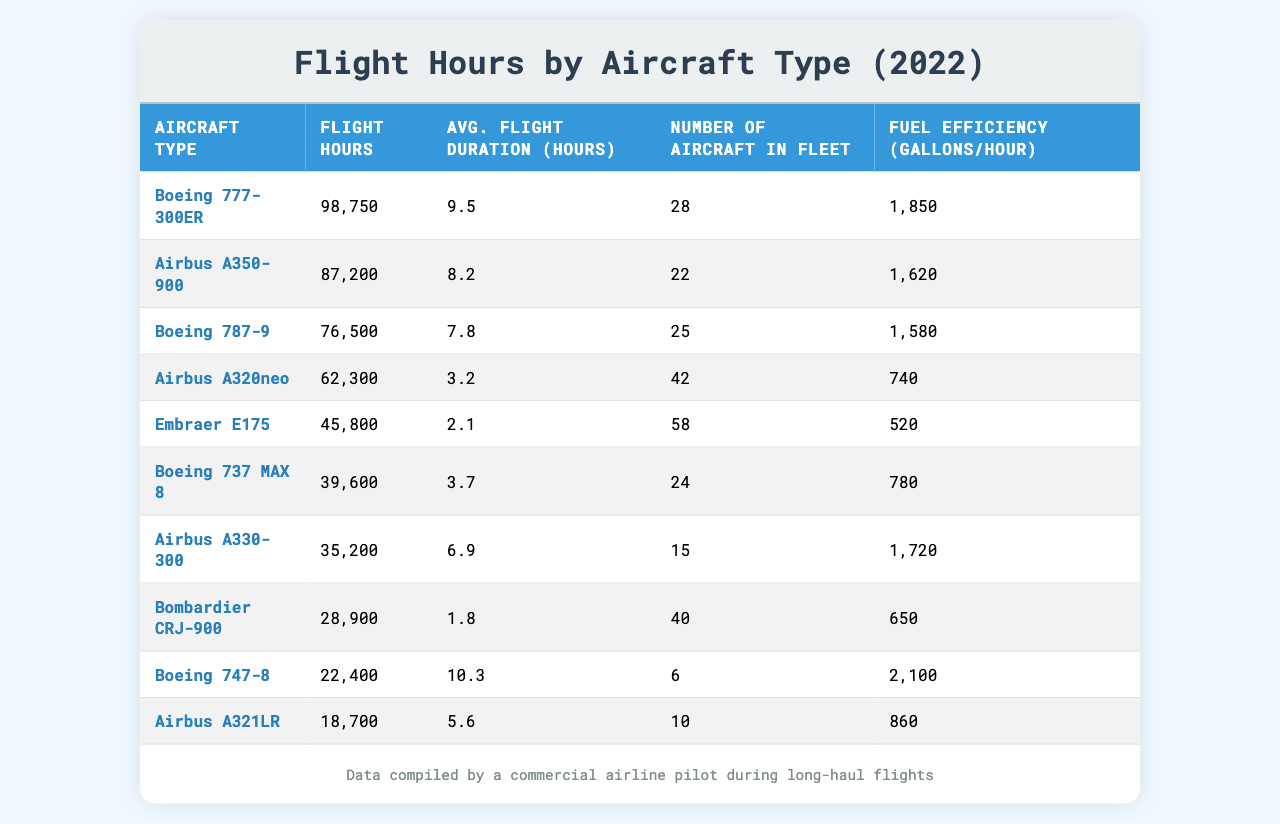What is the total flight hours logged by the Boeing 777-300ER? The table shows the flight hours for the Boeing 777-300ER as 98,750.
Answer: 98,750 Which aircraft type has the highest flight hours? The Boeing 777-300ER has the most flight hours logged at 98,750, which is listed first in the table.
Answer: Boeing 777-300ER What is the average flight duration for the Airbus A350-900? The average flight duration for the Airbus A350-900 is 8.2 hours, as shown directly in the appropriate cell of the table.
Answer: 8.2 How many aircraft are in the fleet for the Boeing 787-9? The number of Boeing 787-9s in the fleet is 25, as indicated in the corresponding row of the table.
Answer: 25 What is the total number of aircraft across all types listed in the table? Summing the number of aircraft in the fleet gives us: 28 + 22 + 25 + 42 + 58 + 24 + 15 + 40 + 6 + 10 = 280.
Answer: 280 Is the fuel efficiency of the Airbus A320neo greater than that of the Embraer E175? The Airbus A320neo has a fuel efficiency of 740 gallons/hour, while the Embraer E175's efficiency is 520 gallons/hour, confirming that the Airbus A320neo is indeed more fuel-efficient.
Answer: Yes What is the average flight duration of the aircraft types that have logged more than 50,000 flight hours? The aircraft types with more than 50,000 flight hours are the Boeing 777-300ER, Airbus A350-900, Boeing 787-9, and Airbus A330-300. Their average flight duration: (9.5 + 8.2 + 7.8 + 6.9) / 4 = 8.35 hours.
Answer: 8.35 Which aircraft type has the least flight hours, and what is its value? The aircraft type with the least flight hours is the Airbus A321LR with 18,700 hours, as indicated at the end of the flight hours list.
Answer: Airbus A321LR, 18,700 How does the total flight hours of the Boeing 747-8 compare to the Boeing 737 MAX 8? The Boeing 747-8 has logged 22,400 hours while the Boeing 737 MAX 8 has 39,600 hours; therefore, the Boeing 737 MAX 8 has more flight hours.
Answer: Boeing 737 MAX 8 has more hours What is the fuel efficiency difference between the Boeing 777-300ER and the Boeing 747-8? The fuel efficiency of the Boeing 777-300ER is 1,850 gallons/hour, and for the Boeing 747-8, it is 2,100 gallons/hour. The difference is 2,100 - 1,850 = 250 gallons/hour.
Answer: 250 gallons/hour 